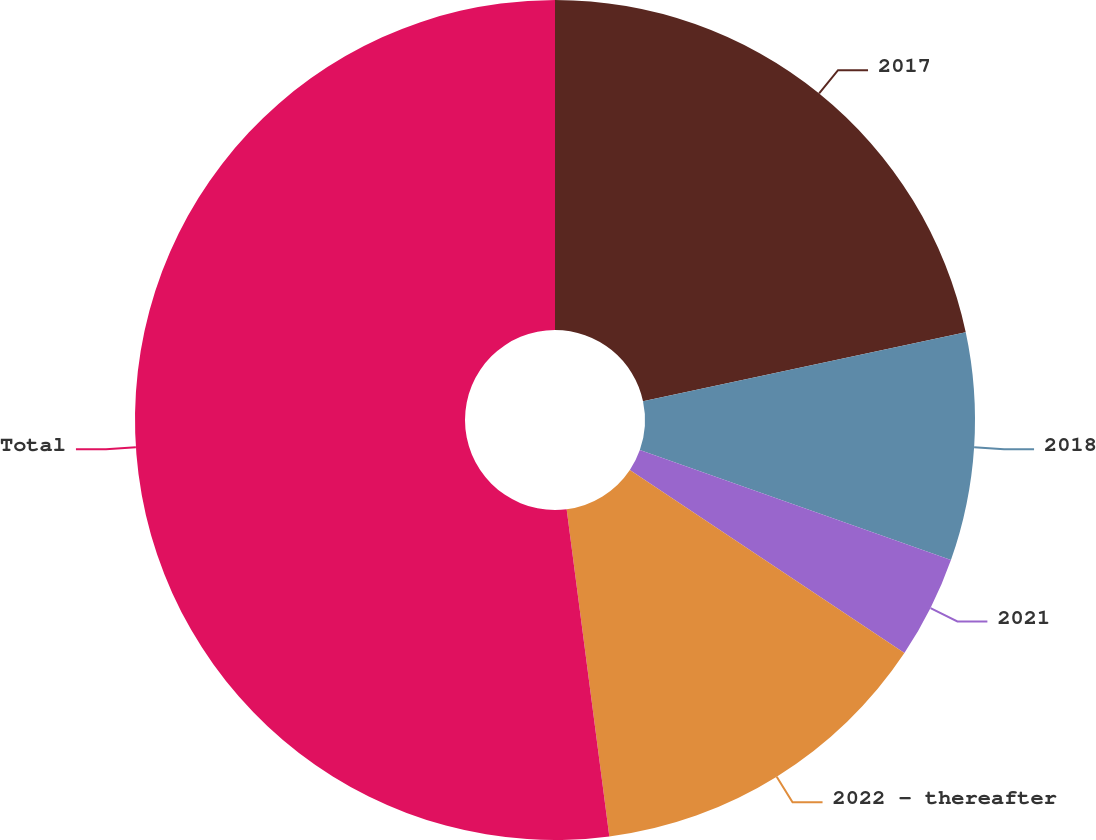<chart> <loc_0><loc_0><loc_500><loc_500><pie_chart><fcel>2017<fcel>2018<fcel>2021<fcel>2022 - thereafter<fcel>Total<nl><fcel>21.65%<fcel>8.76%<fcel>3.95%<fcel>13.57%<fcel>52.06%<nl></chart> 